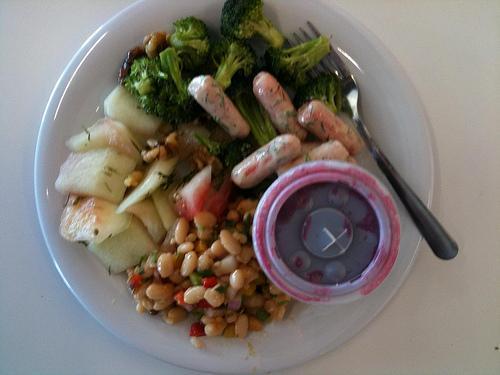How many forks are in the photo?
Give a very brief answer. 1. 